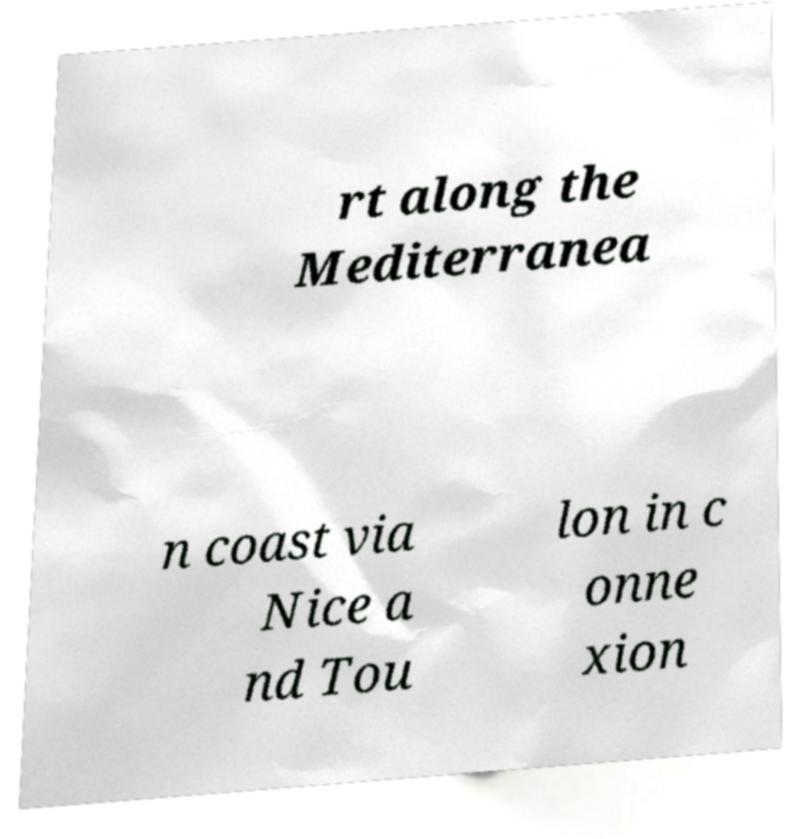I need the written content from this picture converted into text. Can you do that? rt along the Mediterranea n coast via Nice a nd Tou lon in c onne xion 